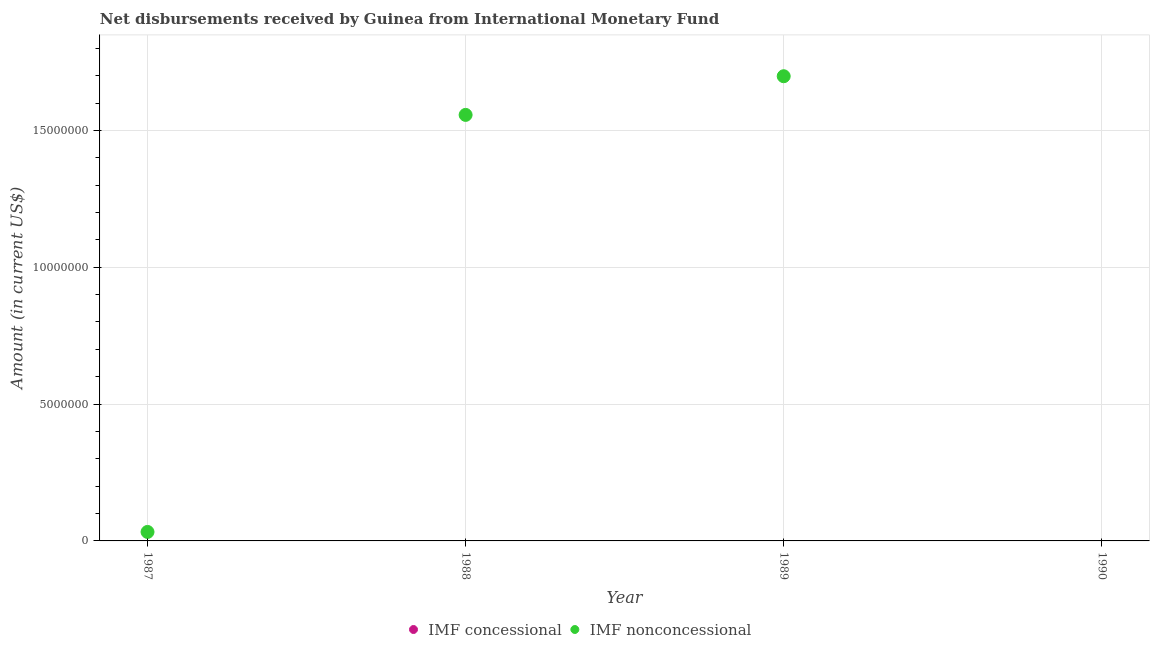Is the number of dotlines equal to the number of legend labels?
Ensure brevity in your answer.  No. What is the net non concessional disbursements from imf in 1988?
Offer a very short reply. 1.56e+07. Across all years, what is the maximum net non concessional disbursements from imf?
Ensure brevity in your answer.  1.70e+07. What is the difference between the net non concessional disbursements from imf in 1987 and that in 1988?
Keep it short and to the point. -1.52e+07. What is the difference between the net non concessional disbursements from imf in 1989 and the net concessional disbursements from imf in 1990?
Your response must be concise. 1.70e+07. What is the average net non concessional disbursements from imf per year?
Make the answer very short. 8.22e+06. What is the ratio of the net non concessional disbursements from imf in 1987 to that in 1988?
Provide a short and direct response. 0.02. What is the difference between the highest and the second highest net non concessional disbursements from imf?
Your response must be concise. 1.41e+06. What is the difference between the highest and the lowest net non concessional disbursements from imf?
Offer a very short reply. 1.70e+07. In how many years, is the net concessional disbursements from imf greater than the average net concessional disbursements from imf taken over all years?
Your answer should be compact. 0. Does the net concessional disbursements from imf monotonically increase over the years?
Your answer should be compact. Yes. Is the net non concessional disbursements from imf strictly less than the net concessional disbursements from imf over the years?
Your answer should be compact. No. How many dotlines are there?
Give a very brief answer. 1. What is the difference between two consecutive major ticks on the Y-axis?
Ensure brevity in your answer.  5.00e+06. Are the values on the major ticks of Y-axis written in scientific E-notation?
Offer a very short reply. No. Does the graph contain any zero values?
Give a very brief answer. Yes. Does the graph contain grids?
Keep it short and to the point. Yes. Where does the legend appear in the graph?
Your answer should be compact. Bottom center. How are the legend labels stacked?
Give a very brief answer. Horizontal. What is the title of the graph?
Provide a short and direct response. Net disbursements received by Guinea from International Monetary Fund. Does "Food and tobacco" appear as one of the legend labels in the graph?
Offer a very short reply. No. What is the Amount (in current US$) in IMF concessional in 1987?
Keep it short and to the point. 0. What is the Amount (in current US$) of IMF nonconcessional in 1987?
Your response must be concise. 3.28e+05. What is the Amount (in current US$) of IMF nonconcessional in 1988?
Provide a succinct answer. 1.56e+07. What is the Amount (in current US$) in IMF nonconcessional in 1989?
Your answer should be very brief. 1.70e+07. What is the Amount (in current US$) of IMF concessional in 1990?
Offer a very short reply. 0. Across all years, what is the maximum Amount (in current US$) of IMF nonconcessional?
Keep it short and to the point. 1.70e+07. Across all years, what is the minimum Amount (in current US$) of IMF nonconcessional?
Provide a succinct answer. 0. What is the total Amount (in current US$) in IMF nonconcessional in the graph?
Keep it short and to the point. 3.29e+07. What is the difference between the Amount (in current US$) in IMF nonconcessional in 1987 and that in 1988?
Offer a very short reply. -1.52e+07. What is the difference between the Amount (in current US$) in IMF nonconcessional in 1987 and that in 1989?
Keep it short and to the point. -1.67e+07. What is the difference between the Amount (in current US$) of IMF nonconcessional in 1988 and that in 1989?
Give a very brief answer. -1.41e+06. What is the average Amount (in current US$) in IMF concessional per year?
Make the answer very short. 0. What is the average Amount (in current US$) in IMF nonconcessional per year?
Your answer should be compact. 8.22e+06. What is the ratio of the Amount (in current US$) in IMF nonconcessional in 1987 to that in 1988?
Ensure brevity in your answer.  0.02. What is the ratio of the Amount (in current US$) in IMF nonconcessional in 1987 to that in 1989?
Your answer should be very brief. 0.02. What is the ratio of the Amount (in current US$) in IMF nonconcessional in 1988 to that in 1989?
Ensure brevity in your answer.  0.92. What is the difference between the highest and the second highest Amount (in current US$) in IMF nonconcessional?
Offer a terse response. 1.41e+06. What is the difference between the highest and the lowest Amount (in current US$) in IMF nonconcessional?
Your response must be concise. 1.70e+07. 